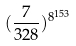<formula> <loc_0><loc_0><loc_500><loc_500>( \frac { 7 } { 3 2 8 } ) ^ { 8 ^ { 1 5 3 } }</formula> 